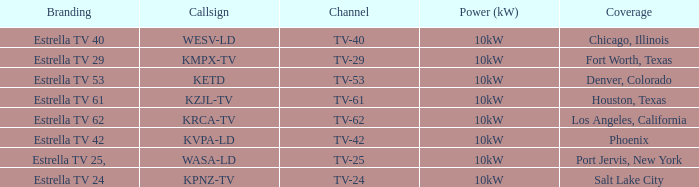What region did estrella tv 62 offer coverage for? Los Angeles, California. Could you help me parse every detail presented in this table? {'header': ['Branding', 'Callsign', 'Channel', 'Power (kW)', 'Coverage'], 'rows': [['Estrella TV 40', 'WESV-LD', 'TV-40', '10kW', 'Chicago, Illinois'], ['Estrella TV 29', 'KMPX-TV', 'TV-29', '10kW', 'Fort Worth, Texas'], ['Estrella TV 53', 'KETD', 'TV-53', '10kW', 'Denver, Colorado'], ['Estrella TV 61', 'KZJL-TV', 'TV-61', '10kW', 'Houston, Texas'], ['Estrella TV 62', 'KRCA-TV', 'TV-62', '10kW', 'Los Angeles, California'], ['Estrella TV 42', 'KVPA-LD', 'TV-42', '10kW', 'Phoenix'], ['Estrella TV 25,', 'WASA-LD', 'TV-25', '10kW', 'Port Jervis, New York'], ['Estrella TV 24', 'KPNZ-TV', 'TV-24', '10kW', 'Salt Lake City']]} 